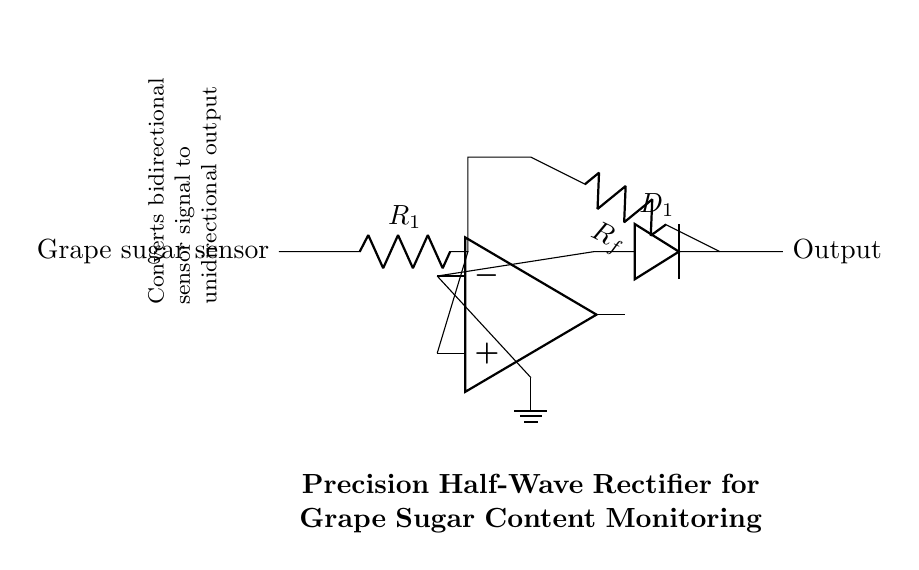What type of rectifier is this circuit? The circuit is a half-wave rectifier, which only allows one half of the input signal to pass through while blocking the other half. This is indicated by the placement of a diode that only allows positive voltage to reach the output.
Answer: half-wave rectifier What component is used to convert the sensor signal? The component used to convert the sensor signal is a diode. In this circuit, diode D1 lets through the positive portion of the signal, effectively rectifying it.
Answer: diode Which component provides feedback in this circuit? The feedback in this circuit is provided by the feedback resistor labeled Rf. This resistor connects the output from the diode back to the inverting input of the op-amp, which is crucial for the precision operation of the rectifier.
Answer: Rf What is the role of the operational amplifier in this circuit? The role of the operational amplifier in this circuit is to amplify the input signal and ensure that the output voltage accurately represents the rectified input from the grape sugar sensor. This allows for better monitoring of the input signal.
Answer: amplify How does this circuit ensure a unidirectional output? This circuit ensures a unidirectional output by using the diode D1, which blocks the negative portion of the input signal, allowing only positive voltages to pass through to the output. The op-amp configuration also supports this unidirectional behavior by controlling the output based on the input's magnitude.
Answer: by using a diode What does the labeling "R1" signify in this circuit? The labeling "R1" signifies a resistor that is part of the input section connected to the grape sugar sensor, which helps limit the current to the op-amp and sets the appropriate gain for the circuit operation.
Answer: a resistor What is the main purpose of this precision half-wave rectifier circuit? The main purpose of this precision half-wave rectifier circuit is to convert the bidirectional output signal from the grape sugar sensor into a unidirectional signal that can be accurately measured and monitored. This is essential for assessing the sugar content in the grapes effectively.
Answer: monitor grape sugar content 